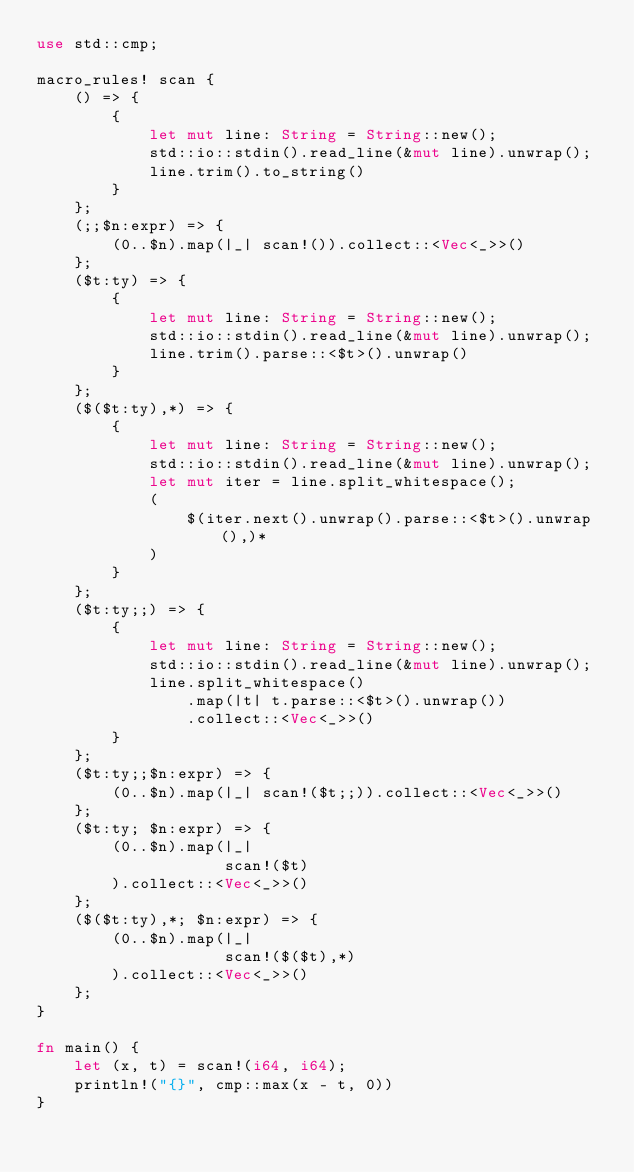<code> <loc_0><loc_0><loc_500><loc_500><_Rust_>use std::cmp;

macro_rules! scan {
    () => {
        {
            let mut line: String = String::new();
            std::io::stdin().read_line(&mut line).unwrap();
            line.trim().to_string()
        }
    };
    (;;$n:expr) => {
        (0..$n).map(|_| scan!()).collect::<Vec<_>>()
    };
    ($t:ty) => {
        {
            let mut line: String = String::new();
            std::io::stdin().read_line(&mut line).unwrap();
            line.trim().parse::<$t>().unwrap()
        }
    };
    ($($t:ty),*) => {
        {
            let mut line: String = String::new();
            std::io::stdin().read_line(&mut line).unwrap();
            let mut iter = line.split_whitespace();
            (
                $(iter.next().unwrap().parse::<$t>().unwrap(),)*
            )
        }
    };
    ($t:ty;;) => {
        {
            let mut line: String = String::new();
            std::io::stdin().read_line(&mut line).unwrap();
            line.split_whitespace()
                .map(|t| t.parse::<$t>().unwrap())
                .collect::<Vec<_>>()
        }
    };
    ($t:ty;;$n:expr) => {
        (0..$n).map(|_| scan!($t;;)).collect::<Vec<_>>()
    };
    ($t:ty; $n:expr) => {
        (0..$n).map(|_|
                    scan!($t)
        ).collect::<Vec<_>>()
    };
    ($($t:ty),*; $n:expr) => {
        (0..$n).map(|_|
                    scan!($($t),*)
        ).collect::<Vec<_>>()
    };
}

fn main() {
    let (x, t) = scan!(i64, i64);
    println!("{}", cmp::max(x - t, 0))
}
</code> 